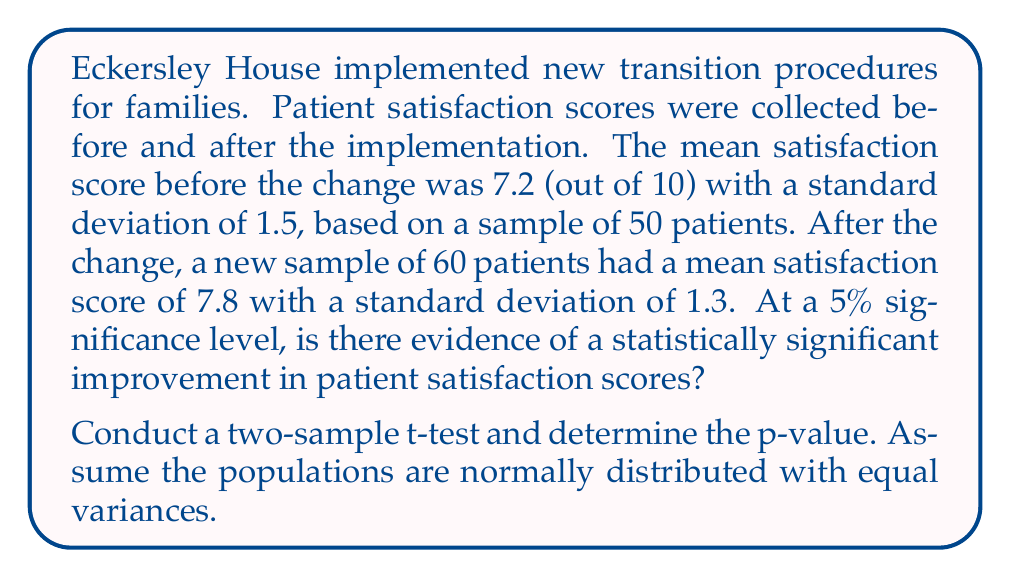Show me your answer to this math problem. To determine if there's a statistically significant improvement, we'll conduct a two-sample t-test:

1. State the hypotheses:
   $H_0: \mu_1 = \mu_2$ (no difference in means)
   $H_a: \mu_1 < \mu_2$ (mean after > mean before)

2. Calculate the pooled standard deviation:
   $$s_p = \sqrt{\frac{(n_1-1)s_1^2 + (n_2-1)s_2^2}{n_1+n_2-2}}$$
   $$s_p = \sqrt{\frac{(50-1)(1.5)^2 + (60-1)(1.3)^2}{50+60-2}} = 1.3964$$

3. Calculate the t-statistic:
   $$t = \frac{\bar{x}_2 - \bar{x}_1}{s_p\sqrt{\frac{1}{n_1}+\frac{1}{n_2}}}$$
   $$t = \frac{7.8 - 7.2}{1.3964\sqrt{\frac{1}{50}+\frac{1}{60}}} = 2.3039$$

4. Degrees of freedom: $df = n_1 + n_2 - 2 = 50 + 60 - 2 = 108$

5. Find the p-value:
   Using a t-distribution table or calculator with $df=108$ and $t=2.3039$, we get:
   $p-value \approx 0.0116$

6. Compare p-value to significance level:
   $0.0116 < 0.05$ (5% significance level)

Since the p-value is less than the significance level, we reject the null hypothesis.
Answer: p-value ≈ 0.0116; Statistically significant improvement 